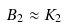<formula> <loc_0><loc_0><loc_500><loc_500>B _ { 2 } \approx K _ { 2 }</formula> 